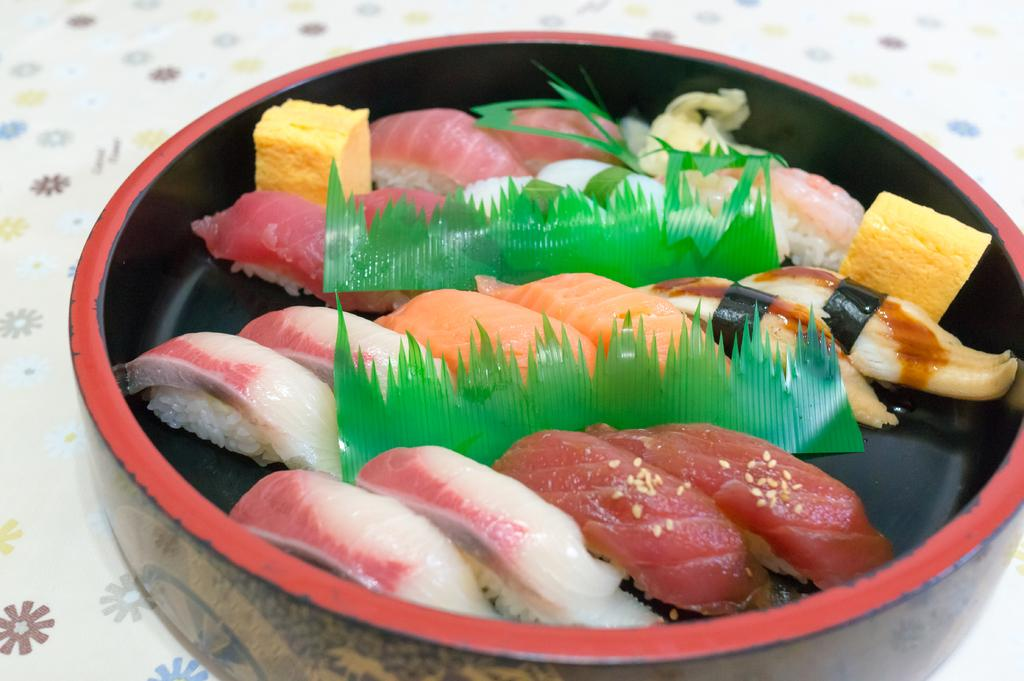What is in the bowl that is visible in the image? There is food in a bowl in the image. Where is the bowl located in the image? The bowl is on a platform. Is there a veil covering the food in the image? No, there is no veil present in the image. What type of liquid can be seen in the bowl with the food? There is no liquid visible in the image; it only shows food in a bowl. 